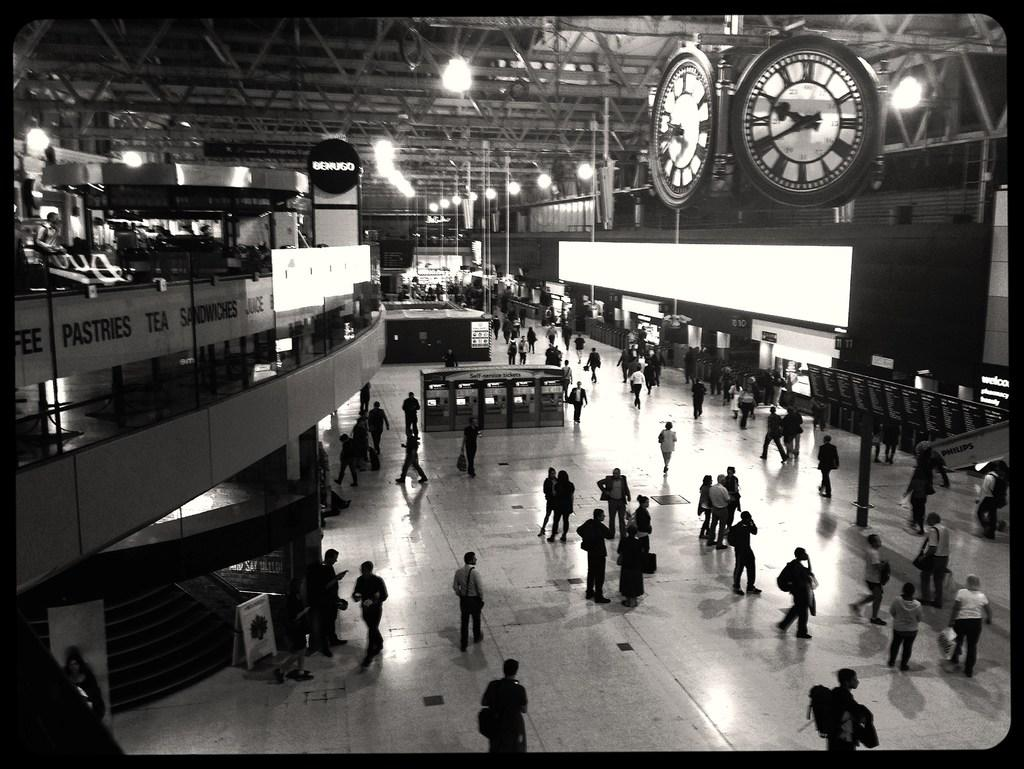What can be seen at the bottom of the image? There are many people and posters at the bottom of the image. What is located in the middle of the image? There are clocks, lights, more posters, some people, text, and poles in the middle of the image. What is the structure above the middle of the image? There is a roof in the middle of the image. What is the opinion of the sand in the image? There is no sand present in the image, so it is not possible to determine its opinion. How many heads can be seen in the image? There is no mention of heads in the provided facts, so it is not possible to determine their number. 